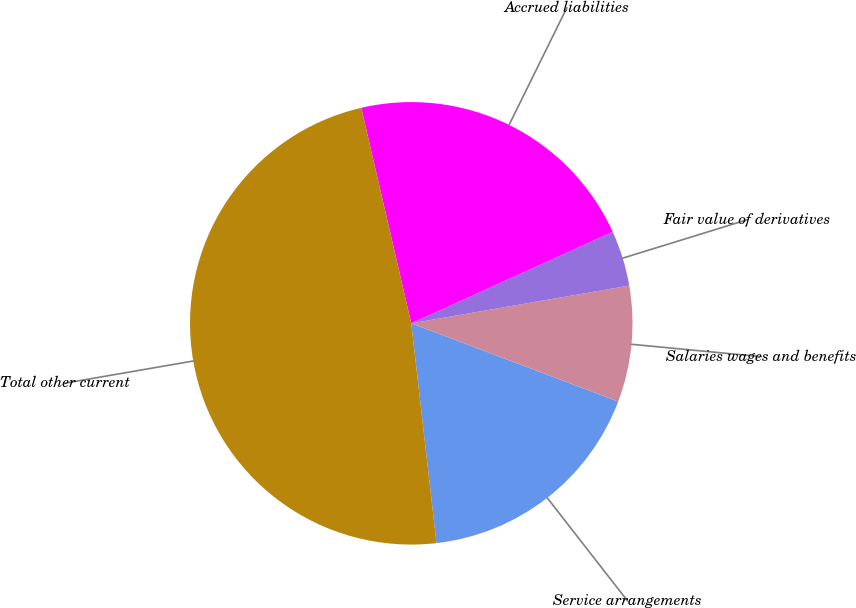<chart> <loc_0><loc_0><loc_500><loc_500><pie_chart><fcel>Service arrangements<fcel>Salaries wages and benefits<fcel>Fair value of derivatives<fcel>Accrued liabilities<fcel>Total other current<nl><fcel>17.43%<fcel>8.48%<fcel>4.06%<fcel>21.84%<fcel>48.19%<nl></chart> 